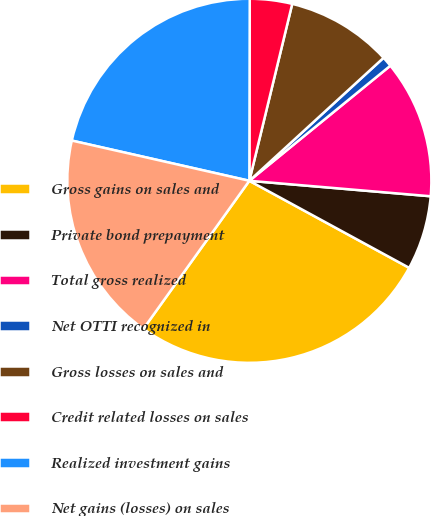Convert chart. <chart><loc_0><loc_0><loc_500><loc_500><pie_chart><fcel>Gross gains on sales and<fcel>Private bond prepayment<fcel>Total gross realized<fcel>Net OTTI recognized in<fcel>Gross losses on sales and<fcel>Credit related losses on sales<fcel>Realized investment gains<fcel>Net gains (losses) on sales<nl><fcel>26.95%<fcel>6.58%<fcel>12.25%<fcel>0.91%<fcel>9.41%<fcel>3.75%<fcel>21.49%<fcel>18.66%<nl></chart> 